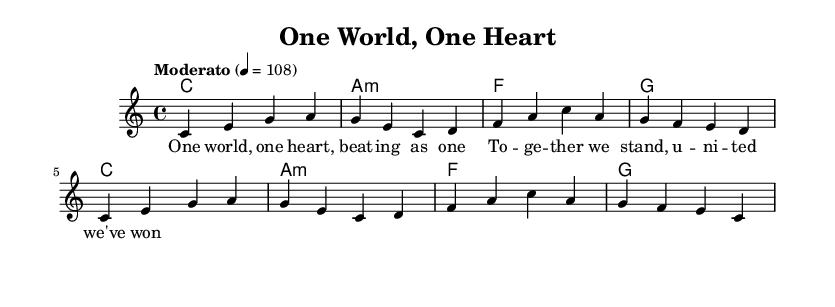What is the key signature of this music? The key signature indicates that the music is in C major, which features no sharps or flats. This is confirmed by examining the key signature indicated at the beginning of the score.
Answer: C major What is the time signature? The time signature displayed at the beginning of the sheet music is 4/4, which means there are four beats in each measure. This can be recognized from the notation indicating how the beats are grouped.
Answer: 4/4 What is the tempo marking? The tempo marking shows "Moderato," indicating a moderate speed for the piece. The specific beat per minute is detailed as 4 = 108, meaning the quarter note is played at a speed of 108 beats per minute.
Answer: Moderato How many measures are in the melody part? By counting the vertical bar lines in the melody section, we can determine the number of measures. In this case, there are 8 measures total. Each bar line signifies the end of a measure.
Answer: 8 What is the first chord of the composition? The first chord indicated in the chord progression is C major, which is noted specifically in the chord names section at the start of the piece.
Answer: C What phrase is associated with the melody in the lyrics? The lyrics aligned with the melody introduce a theme of unity with the phrase "One world, one heart, beating as one." This can be identified by observing the text placed directly under the corresponding melody notes.
Answer: "One world, one heart, beating as one." How are the harmony changes structured in this song? The harmony changes follow a specific progression: C major, A minor, F major, and G major. This can be deduced by analyzing the sequence of chords listed in the chord changes section next to the respective measures.
Answer: C, A minor, F, G 